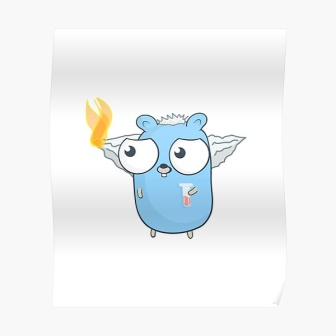What could be the backstory of this creature? This intriguing creature hails from a magical realm deep in the heart of the Whispering Woods. Known locally as the 'Bluesy Guardian,' it's part of a lineage entrusted with maintaining the forest’s mystical balance. One day, while patrolling the enchanted borders, the guardian encountered a malicious fire spirit intent on destruction. In an act of selflessness, the guardian absorbed the flame, preventing widespread havoc but at a cost to its own health. Hence, the flame on its head symbolizes its bravery and the lingering effects of that encounter. The thermometer reflects a perpetual struggle to heal from this noble sacrifice. 